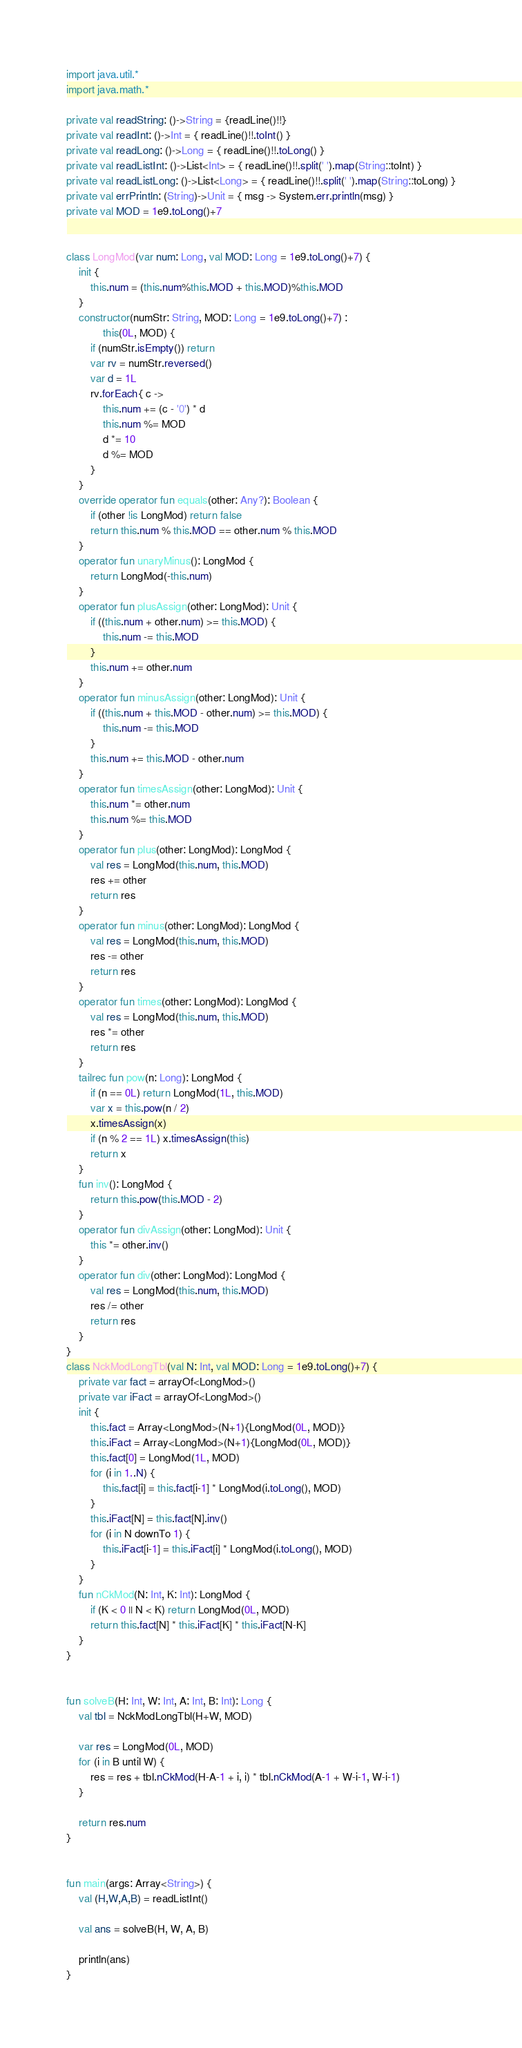<code> <loc_0><loc_0><loc_500><loc_500><_Kotlin_>import java.util.*
import java.math.*

private val readString: ()->String = {readLine()!!}
private val readInt: ()->Int = { readLine()!!.toInt() }
private val readLong: ()->Long = { readLine()!!.toLong() }
private val readListInt: ()->List<Int> = { readLine()!!.split(' ').map(String::toInt) }
private val readListLong: ()->List<Long> = { readLine()!!.split(' ').map(String::toLong) }
private val errPrintln: (String)->Unit = { msg -> System.err.println(msg) }
private val MOD = 1e9.toLong()+7


class LongMod(var num: Long, val MOD: Long = 1e9.toLong()+7) {
    init {
        this.num = (this.num%this.MOD + this.MOD)%this.MOD
    }
    constructor(numStr: String, MOD: Long = 1e9.toLong()+7) :
            this(0L, MOD) {
        if (numStr.isEmpty()) return
        var rv = numStr.reversed()
        var d = 1L
        rv.forEach{ c ->
            this.num += (c - '0') * d
            this.num %= MOD
            d *= 10
            d %= MOD
        }
    }
    override operator fun equals(other: Any?): Boolean {
        if (other !is LongMod) return false
        return this.num % this.MOD == other.num % this.MOD
    }
    operator fun unaryMinus(): LongMod {
        return LongMod(-this.num)
    }
    operator fun plusAssign(other: LongMod): Unit {
        if ((this.num + other.num) >= this.MOD) {
            this.num -= this.MOD
        }
        this.num += other.num
    }
    operator fun minusAssign(other: LongMod): Unit {
        if ((this.num + this.MOD - other.num) >= this.MOD) {
            this.num -= this.MOD
        }
        this.num += this.MOD - other.num
    }
    operator fun timesAssign(other: LongMod): Unit {
        this.num *= other.num
        this.num %= this.MOD
    }
    operator fun plus(other: LongMod): LongMod {
        val res = LongMod(this.num, this.MOD)
        res += other
        return res
    }
    operator fun minus(other: LongMod): LongMod {
        val res = LongMod(this.num, this.MOD)
        res -= other
        return res
    }
    operator fun times(other: LongMod): LongMod {
        val res = LongMod(this.num, this.MOD)
        res *= other
        return res
    }
    tailrec fun pow(n: Long): LongMod {
        if (n == 0L) return LongMod(1L, this.MOD)
        var x = this.pow(n / 2)
        x.timesAssign(x)
        if (n % 2 == 1L) x.timesAssign(this)
        return x
    }
    fun inv(): LongMod {
        return this.pow(this.MOD - 2)
    }
    operator fun divAssign(other: LongMod): Unit {
        this *= other.inv()
    }
    operator fun div(other: LongMod): LongMod {
        val res = LongMod(this.num, this.MOD)
        res /= other
        return res
    }
}
class NckModLongTbl(val N: Int, val MOD: Long = 1e9.toLong()+7) {
    private var fact = arrayOf<LongMod>()
    private var iFact = arrayOf<LongMod>()
    init {
        this.fact = Array<LongMod>(N+1){LongMod(0L, MOD)}
        this.iFact = Array<LongMod>(N+1){LongMod(0L, MOD)}
        this.fact[0] = LongMod(1L, MOD)
        for (i in 1..N) {
            this.fact[i] = this.fact[i-1] * LongMod(i.toLong(), MOD)
        }
        this.iFact[N] = this.fact[N].inv()
        for (i in N downTo 1) {
            this.iFact[i-1] = this.iFact[i] * LongMod(i.toLong(), MOD)
        }
    }
    fun nCkMod(N: Int, K: Int): LongMod {
        if (K < 0 || N < K) return LongMod(0L, MOD)
        return this.fact[N] * this.iFact[K] * this.iFact[N-K]
    }
}


fun solveB(H: Int, W: Int, A: Int, B: Int): Long {
    val tbl = NckModLongTbl(H+W, MOD)

    var res = LongMod(0L, MOD)
    for (i in B until W) {
        res = res + tbl.nCkMod(H-A-1 + i, i) * tbl.nCkMod(A-1 + W-i-1, W-i-1)
    }

    return res.num
}


fun main(args: Array<String>) {
    val (H,W,A,B) = readListInt()

    val ans = solveB(H, W, A, B)

    println(ans)
}
</code> 